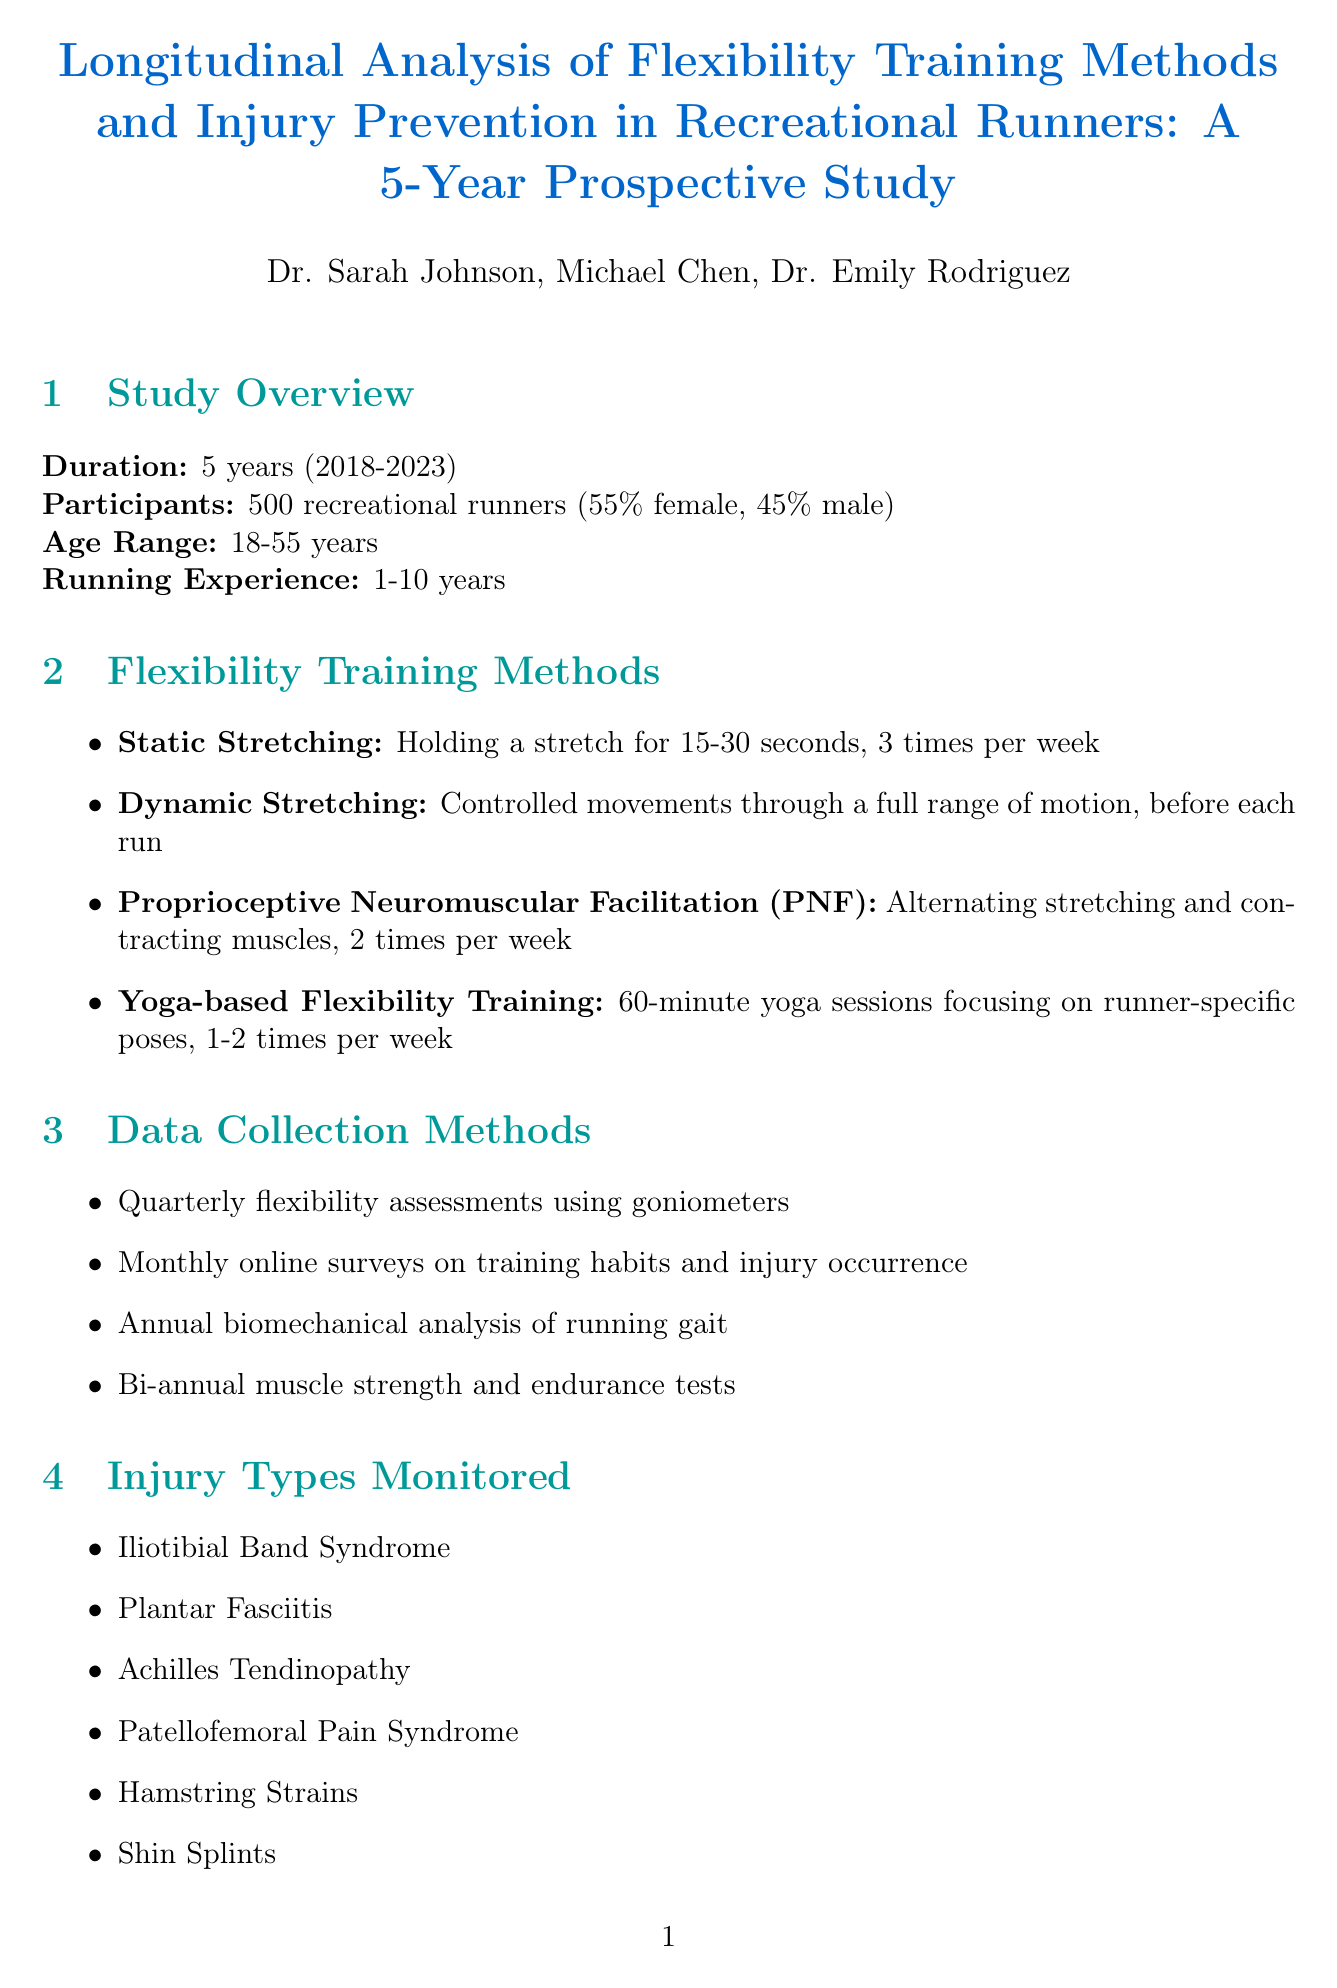What is the title of the study? The title of the study is presented at the beginning of the document.
Answer: Longitudinal Analysis of Flexibility Training Methods and Injury Prevention in Recreational Runners: A 5-Year Prospective Study Who is the Principal Investigator? The Principal Investigator's name is listed in the research team section of the document.
Answer: Dr. Sarah Johnson What is the age range of participants? The age range is specified in the overview section of the document.
Answer: 18-55 years How many participants were involved in the study? The total number of participants is stated in the document.
Answer: 500 Which flexibility training method showed the highest correlation with reduced injury rates? The findings section of the document indicates which method had the highest correlation.
Answer: Dynamic stretching What is one of the injury types monitored in the study? The document lists various types of injuries monitored throughout the study.
Answer: Iliotibial Band Syndrome What statistical analysis was used for injury risk analysis? The statistical analysis section specifies which method was used for this purpose.
Answer: Cox proportional hazards regression What is a limitation mentioned in the document? Limitations are outlined in a specific section, highlighting areas for future research.
Answer: Need for longer-term studies to assess chronic effects of flexibility training What is the funding source of the study? The funding source is mentioned at the end of the document.
Answer: National Institutes of Health (NIH) - National Institute of Arthritis and Musculoskeletal and Skin Diseases (NIAMS) 